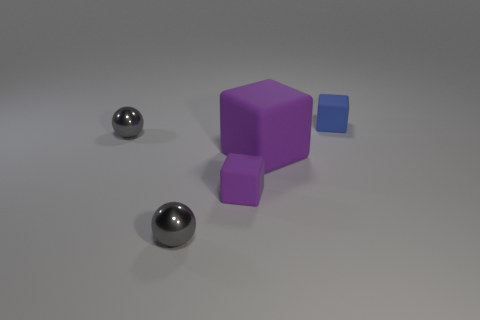What size is the matte object that is both to the right of the small purple rubber thing and in front of the blue rubber cube?
Offer a terse response. Large. How many other things are the same shape as the large purple object?
Make the answer very short. 2. What size is the other purple thing that is the same shape as the small purple object?
Provide a short and direct response. Large. The object that is both behind the large purple object and to the right of the small purple matte thing is what color?
Your response must be concise. Blue. What number of objects are either things that are behind the small purple rubber block or gray metal spheres?
Keep it short and to the point. 4. What color is the big object that is the same shape as the small blue rubber thing?
Your answer should be very brief. Purple. There is a blue thing; does it have the same shape as the small metallic thing that is behind the small purple rubber thing?
Your answer should be very brief. No. How many objects are tiny gray metal spheres behind the large thing or things left of the large purple matte cube?
Give a very brief answer. 3. Are there fewer cubes behind the small purple thing than purple things?
Your response must be concise. No. Do the blue object and the small sphere behind the large block have the same material?
Your answer should be very brief. No. 